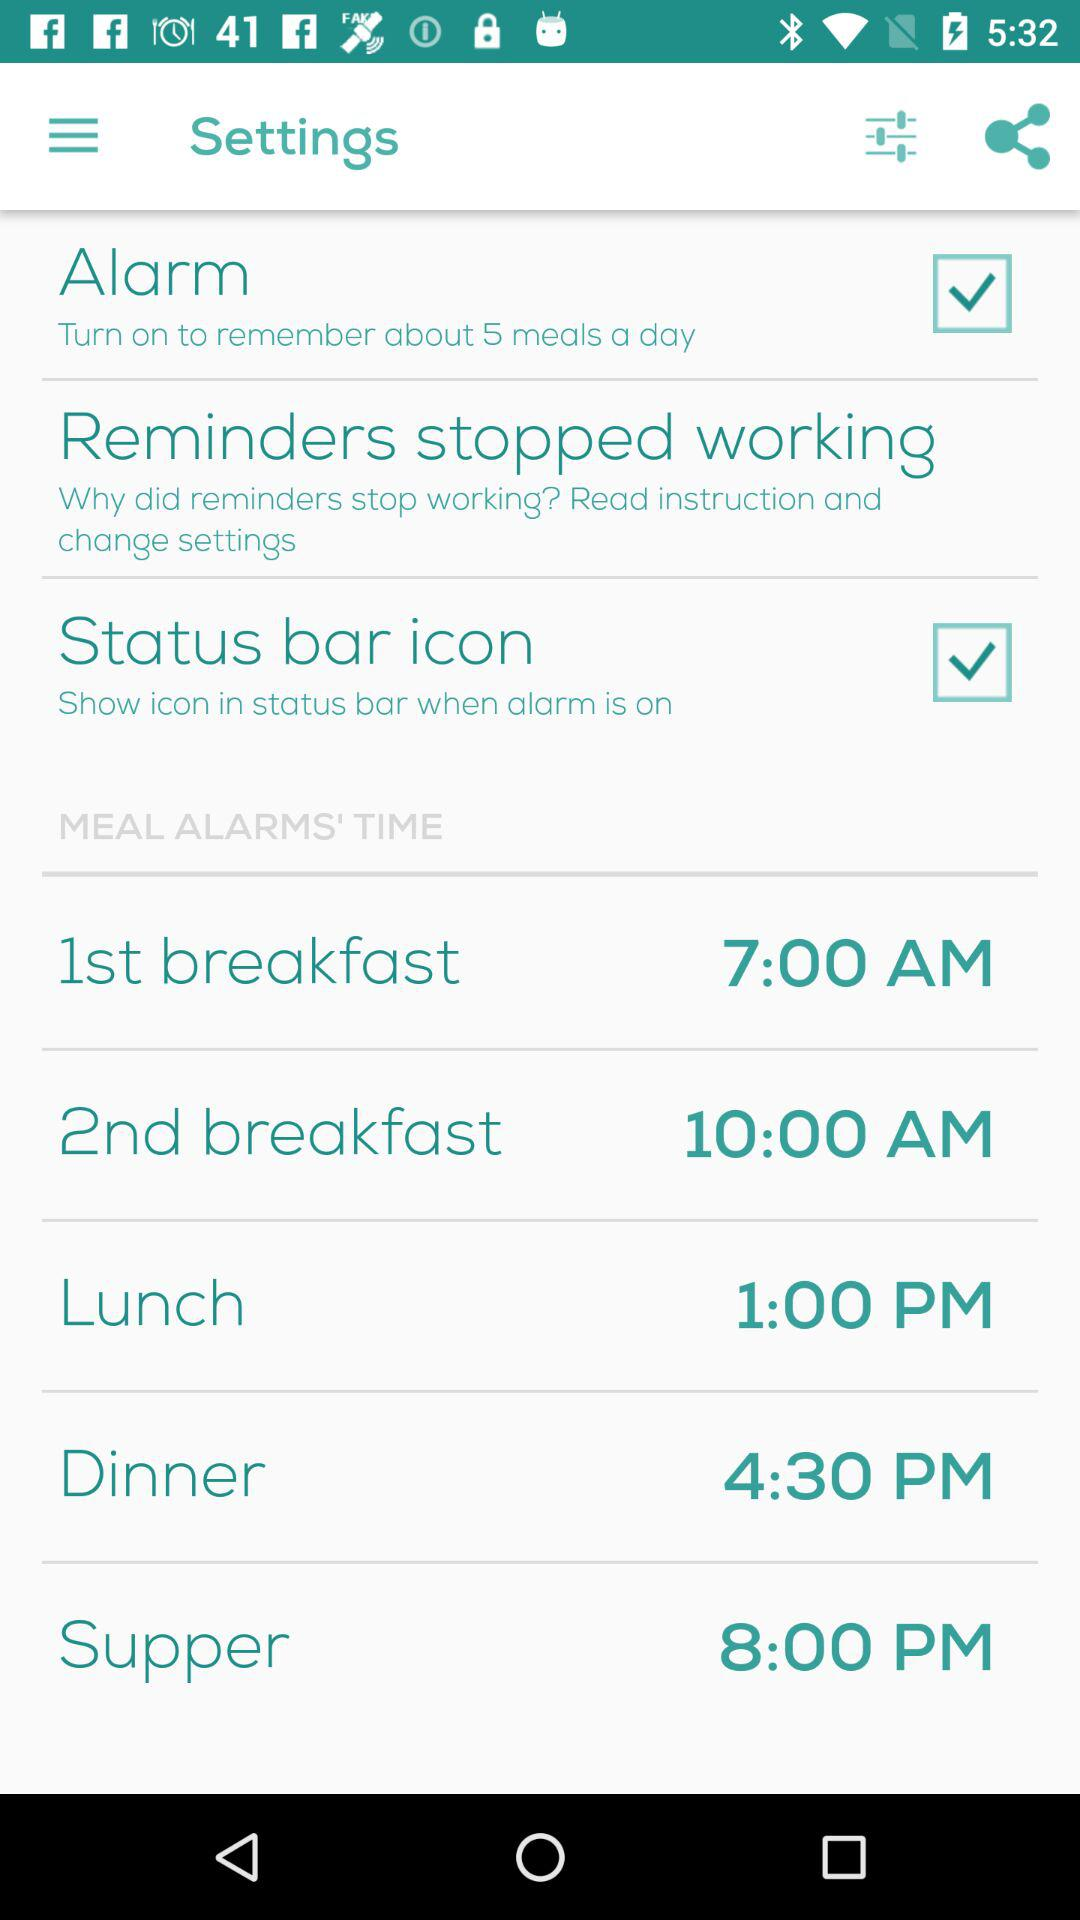How can we set the time zone?
When the provided information is insufficient, respond with <no answer>. <no answer> 